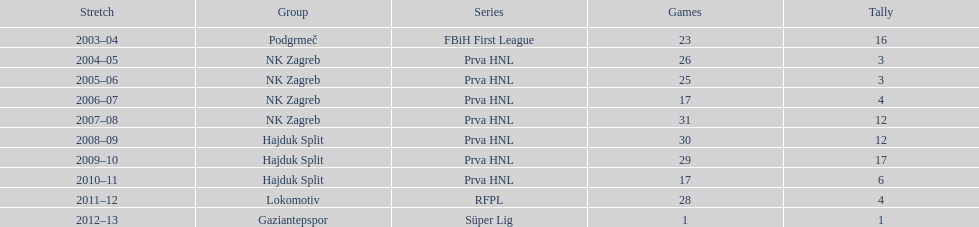At most 26 apps, how many goals were scored in 2004-2005 3. 